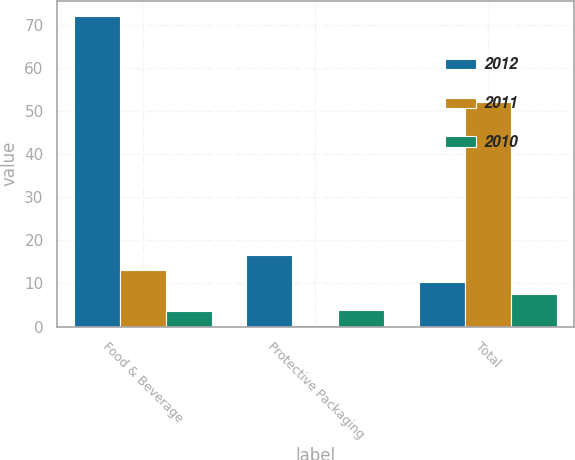<chart> <loc_0><loc_0><loc_500><loc_500><stacked_bar_chart><ecel><fcel>Food & Beverage<fcel>Protective Packaging<fcel>Total<nl><fcel>2012<fcel>72<fcel>16.7<fcel>10.35<nl><fcel>2011<fcel>13.1<fcel>0.4<fcel>52.2<nl><fcel>2010<fcel>3.7<fcel>3.9<fcel>7.6<nl></chart> 